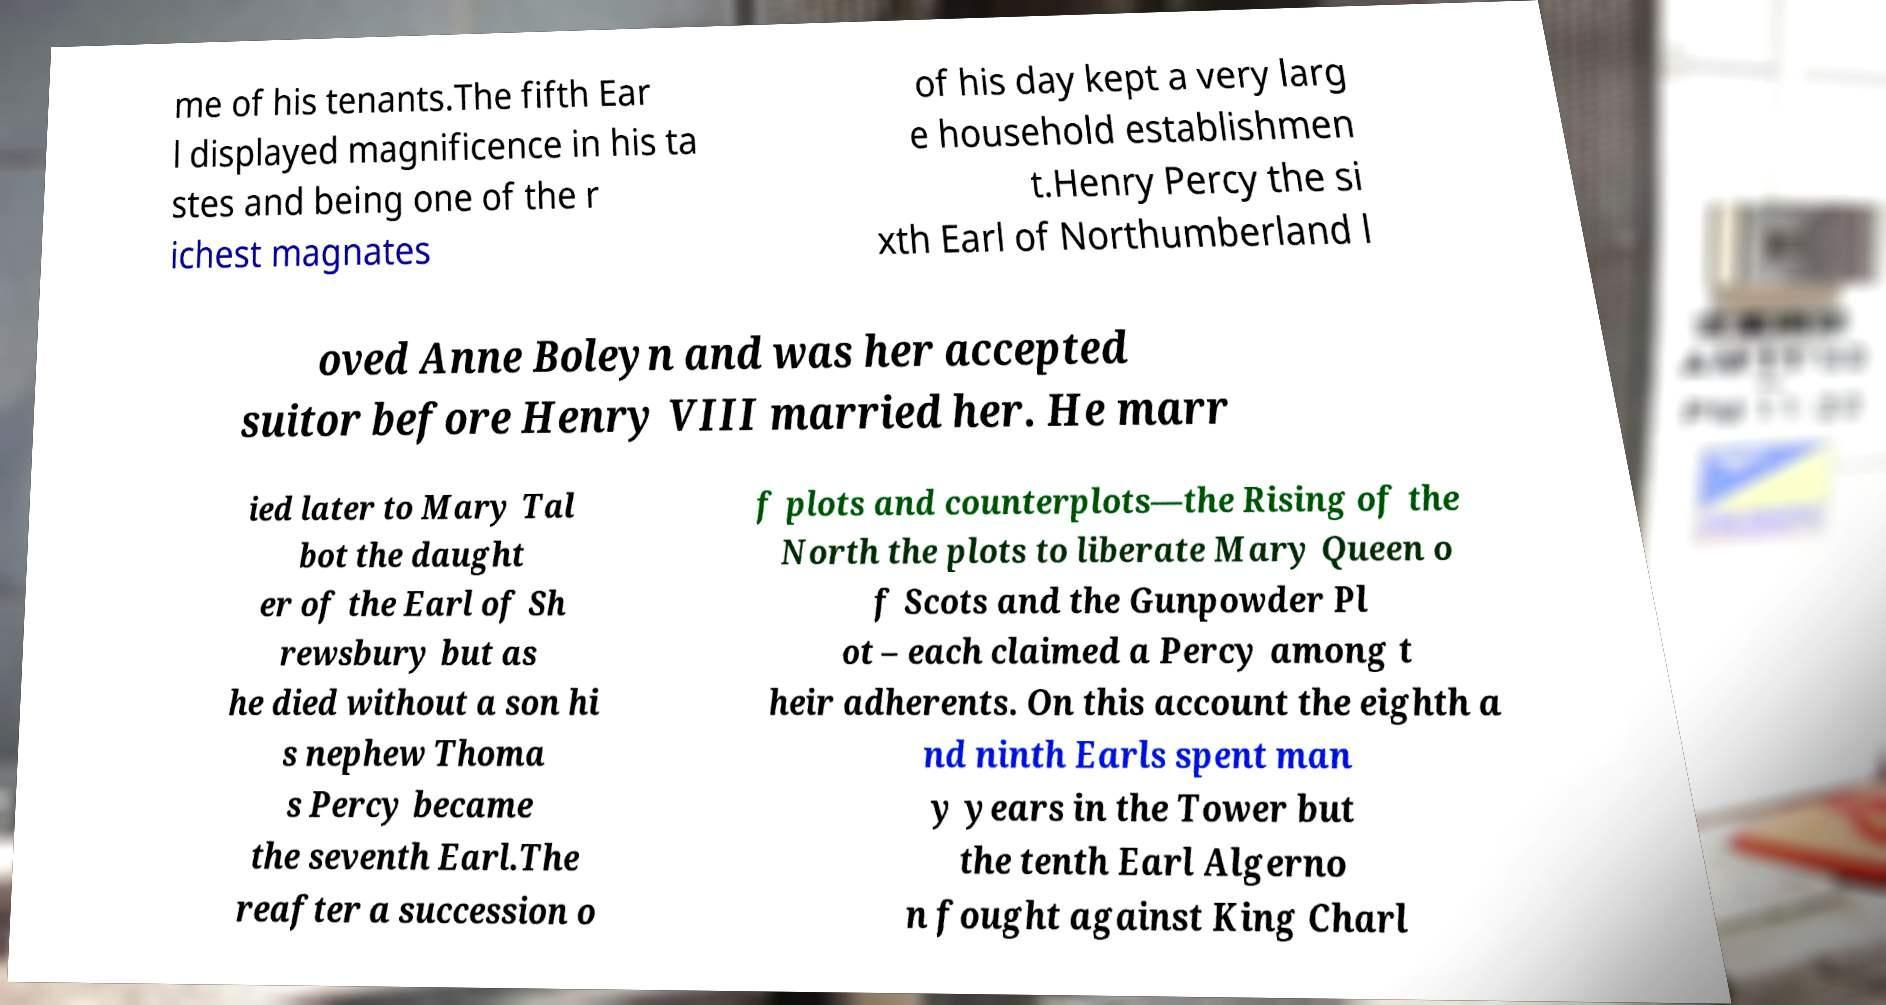Please identify and transcribe the text found in this image. me of his tenants.The fifth Ear l displayed magnificence in his ta stes and being one of the r ichest magnates of his day kept a very larg e household establishmen t.Henry Percy the si xth Earl of Northumberland l oved Anne Boleyn and was her accepted suitor before Henry VIII married her. He marr ied later to Mary Tal bot the daught er of the Earl of Sh rewsbury but as he died without a son hi s nephew Thoma s Percy became the seventh Earl.The reafter a succession o f plots and counterplots—the Rising of the North the plots to liberate Mary Queen o f Scots and the Gunpowder Pl ot – each claimed a Percy among t heir adherents. On this account the eighth a nd ninth Earls spent man y years in the Tower but the tenth Earl Algerno n fought against King Charl 